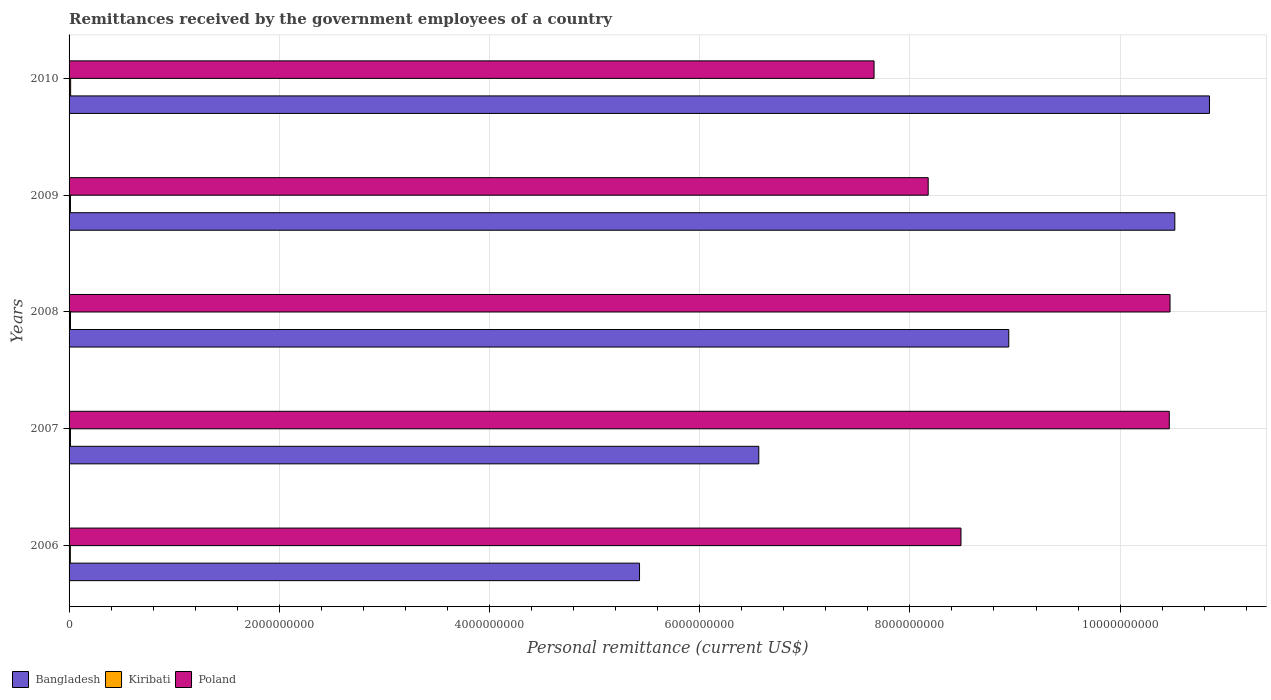Are the number of bars per tick equal to the number of legend labels?
Give a very brief answer. Yes. How many bars are there on the 2nd tick from the top?
Provide a short and direct response. 3. How many bars are there on the 1st tick from the bottom?
Ensure brevity in your answer.  3. What is the label of the 4th group of bars from the top?
Keep it short and to the point. 2007. What is the remittances received by the government employees in Poland in 2007?
Your answer should be very brief. 1.05e+1. Across all years, what is the maximum remittances received by the government employees in Bangladesh?
Your answer should be compact. 1.09e+1. Across all years, what is the minimum remittances received by the government employees in Poland?
Provide a short and direct response. 7.66e+09. What is the total remittances received by the government employees in Kiribati in the graph?
Make the answer very short. 6.64e+07. What is the difference between the remittances received by the government employees in Kiribati in 2006 and that in 2009?
Your answer should be very brief. -1.09e+06. What is the difference between the remittances received by the government employees in Bangladesh in 2010 and the remittances received by the government employees in Kiribati in 2006?
Offer a terse response. 1.08e+1. What is the average remittances received by the government employees in Kiribati per year?
Make the answer very short. 1.33e+07. In the year 2007, what is the difference between the remittances received by the government employees in Kiribati and remittances received by the government employees in Poland?
Your response must be concise. -1.05e+1. What is the ratio of the remittances received by the government employees in Kiribati in 2009 to that in 2010?
Offer a very short reply. 0.88. What is the difference between the highest and the second highest remittances received by the government employees in Kiribati?
Provide a short and direct response. 1.62e+06. What is the difference between the highest and the lowest remittances received by the government employees in Poland?
Keep it short and to the point. 2.82e+09. Is the sum of the remittances received by the government employees in Kiribati in 2006 and 2008 greater than the maximum remittances received by the government employees in Bangladesh across all years?
Ensure brevity in your answer.  No. What does the 2nd bar from the top in 2009 represents?
Offer a very short reply. Kiribati. How many bars are there?
Your answer should be very brief. 15. How many years are there in the graph?
Your answer should be compact. 5. What is the difference between two consecutive major ticks on the X-axis?
Provide a short and direct response. 2.00e+09. Does the graph contain grids?
Offer a very short reply. Yes. Where does the legend appear in the graph?
Make the answer very short. Bottom left. How are the legend labels stacked?
Give a very brief answer. Horizontal. What is the title of the graph?
Your answer should be compact. Remittances received by the government employees of a country. Does "Vietnam" appear as one of the legend labels in the graph?
Offer a very short reply. No. What is the label or title of the X-axis?
Your answer should be compact. Personal remittance (current US$). What is the Personal remittance (current US$) of Bangladesh in 2006?
Your answer should be compact. 5.43e+09. What is the Personal remittance (current US$) of Kiribati in 2006?
Make the answer very short. 1.21e+07. What is the Personal remittance (current US$) of Poland in 2006?
Offer a terse response. 8.49e+09. What is the Personal remittance (current US$) of Bangladesh in 2007?
Provide a succinct answer. 6.56e+09. What is the Personal remittance (current US$) in Kiribati in 2007?
Your response must be concise. 1.29e+07. What is the Personal remittance (current US$) of Poland in 2007?
Keep it short and to the point. 1.05e+1. What is the Personal remittance (current US$) in Bangladesh in 2008?
Make the answer very short. 8.94e+09. What is the Personal remittance (current US$) in Kiribati in 2008?
Provide a short and direct response. 1.33e+07. What is the Personal remittance (current US$) of Poland in 2008?
Provide a short and direct response. 1.05e+1. What is the Personal remittance (current US$) in Bangladesh in 2009?
Offer a very short reply. 1.05e+1. What is the Personal remittance (current US$) in Kiribati in 2009?
Keep it short and to the point. 1.32e+07. What is the Personal remittance (current US$) of Poland in 2009?
Give a very brief answer. 8.17e+09. What is the Personal remittance (current US$) of Bangladesh in 2010?
Offer a terse response. 1.09e+1. What is the Personal remittance (current US$) in Kiribati in 2010?
Provide a succinct answer. 1.49e+07. What is the Personal remittance (current US$) in Poland in 2010?
Give a very brief answer. 7.66e+09. Across all years, what is the maximum Personal remittance (current US$) in Bangladesh?
Provide a succinct answer. 1.09e+1. Across all years, what is the maximum Personal remittance (current US$) in Kiribati?
Make the answer very short. 1.49e+07. Across all years, what is the maximum Personal remittance (current US$) in Poland?
Provide a short and direct response. 1.05e+1. Across all years, what is the minimum Personal remittance (current US$) in Bangladesh?
Give a very brief answer. 5.43e+09. Across all years, what is the minimum Personal remittance (current US$) of Kiribati?
Offer a terse response. 1.21e+07. Across all years, what is the minimum Personal remittance (current US$) of Poland?
Offer a very short reply. 7.66e+09. What is the total Personal remittance (current US$) in Bangladesh in the graph?
Keep it short and to the point. 4.23e+1. What is the total Personal remittance (current US$) in Kiribati in the graph?
Give a very brief answer. 6.64e+07. What is the total Personal remittance (current US$) of Poland in the graph?
Provide a short and direct response. 4.53e+1. What is the difference between the Personal remittance (current US$) in Bangladesh in 2006 and that in 2007?
Ensure brevity in your answer.  -1.13e+09. What is the difference between the Personal remittance (current US$) in Kiribati in 2006 and that in 2007?
Keep it short and to the point. -8.37e+05. What is the difference between the Personal remittance (current US$) in Poland in 2006 and that in 2007?
Ensure brevity in your answer.  -1.98e+09. What is the difference between the Personal remittance (current US$) in Bangladesh in 2006 and that in 2008?
Offer a terse response. -3.51e+09. What is the difference between the Personal remittance (current US$) of Kiribati in 2006 and that in 2008?
Make the answer very short. -1.21e+06. What is the difference between the Personal remittance (current US$) in Poland in 2006 and that in 2008?
Make the answer very short. -1.99e+09. What is the difference between the Personal remittance (current US$) of Bangladesh in 2006 and that in 2009?
Make the answer very short. -5.09e+09. What is the difference between the Personal remittance (current US$) in Kiribati in 2006 and that in 2009?
Give a very brief answer. -1.09e+06. What is the difference between the Personal remittance (current US$) in Poland in 2006 and that in 2009?
Your answer should be compact. 3.12e+08. What is the difference between the Personal remittance (current US$) in Bangladesh in 2006 and that in 2010?
Your answer should be compact. -5.42e+09. What is the difference between the Personal remittance (current US$) in Kiribati in 2006 and that in 2010?
Ensure brevity in your answer.  -2.83e+06. What is the difference between the Personal remittance (current US$) of Poland in 2006 and that in 2010?
Your answer should be very brief. 8.27e+08. What is the difference between the Personal remittance (current US$) of Bangladesh in 2007 and that in 2008?
Ensure brevity in your answer.  -2.38e+09. What is the difference between the Personal remittance (current US$) in Kiribati in 2007 and that in 2008?
Make the answer very short. -3.76e+05. What is the difference between the Personal remittance (current US$) in Poland in 2007 and that in 2008?
Your answer should be compact. -7.00e+06. What is the difference between the Personal remittance (current US$) of Bangladesh in 2007 and that in 2009?
Provide a short and direct response. -3.96e+09. What is the difference between the Personal remittance (current US$) in Kiribati in 2007 and that in 2009?
Provide a succinct answer. -2.53e+05. What is the difference between the Personal remittance (current US$) in Poland in 2007 and that in 2009?
Your answer should be compact. 2.29e+09. What is the difference between the Personal remittance (current US$) of Bangladesh in 2007 and that in 2010?
Make the answer very short. -4.29e+09. What is the difference between the Personal remittance (current US$) of Kiribati in 2007 and that in 2010?
Ensure brevity in your answer.  -1.99e+06. What is the difference between the Personal remittance (current US$) of Poland in 2007 and that in 2010?
Offer a terse response. 2.81e+09. What is the difference between the Personal remittance (current US$) of Bangladesh in 2008 and that in 2009?
Give a very brief answer. -1.58e+09. What is the difference between the Personal remittance (current US$) in Kiribati in 2008 and that in 2009?
Offer a very short reply. 1.23e+05. What is the difference between the Personal remittance (current US$) of Poland in 2008 and that in 2009?
Your response must be concise. 2.30e+09. What is the difference between the Personal remittance (current US$) in Bangladesh in 2008 and that in 2010?
Provide a short and direct response. -1.91e+09. What is the difference between the Personal remittance (current US$) in Kiribati in 2008 and that in 2010?
Your answer should be compact. -1.62e+06. What is the difference between the Personal remittance (current US$) of Poland in 2008 and that in 2010?
Keep it short and to the point. 2.82e+09. What is the difference between the Personal remittance (current US$) of Bangladesh in 2009 and that in 2010?
Give a very brief answer. -3.30e+08. What is the difference between the Personal remittance (current US$) in Kiribati in 2009 and that in 2010?
Ensure brevity in your answer.  -1.74e+06. What is the difference between the Personal remittance (current US$) of Poland in 2009 and that in 2010?
Offer a very short reply. 5.15e+08. What is the difference between the Personal remittance (current US$) in Bangladesh in 2006 and the Personal remittance (current US$) in Kiribati in 2007?
Ensure brevity in your answer.  5.41e+09. What is the difference between the Personal remittance (current US$) of Bangladesh in 2006 and the Personal remittance (current US$) of Poland in 2007?
Provide a succinct answer. -5.04e+09. What is the difference between the Personal remittance (current US$) in Kiribati in 2006 and the Personal remittance (current US$) in Poland in 2007?
Your response must be concise. -1.05e+1. What is the difference between the Personal remittance (current US$) in Bangladesh in 2006 and the Personal remittance (current US$) in Kiribati in 2008?
Your answer should be compact. 5.41e+09. What is the difference between the Personal remittance (current US$) in Bangladesh in 2006 and the Personal remittance (current US$) in Poland in 2008?
Keep it short and to the point. -5.05e+09. What is the difference between the Personal remittance (current US$) of Kiribati in 2006 and the Personal remittance (current US$) of Poland in 2008?
Your answer should be very brief. -1.05e+1. What is the difference between the Personal remittance (current US$) in Bangladesh in 2006 and the Personal remittance (current US$) in Kiribati in 2009?
Give a very brief answer. 5.41e+09. What is the difference between the Personal remittance (current US$) in Bangladesh in 2006 and the Personal remittance (current US$) in Poland in 2009?
Give a very brief answer. -2.75e+09. What is the difference between the Personal remittance (current US$) in Kiribati in 2006 and the Personal remittance (current US$) in Poland in 2009?
Give a very brief answer. -8.16e+09. What is the difference between the Personal remittance (current US$) in Bangladesh in 2006 and the Personal remittance (current US$) in Kiribati in 2010?
Make the answer very short. 5.41e+09. What is the difference between the Personal remittance (current US$) in Bangladesh in 2006 and the Personal remittance (current US$) in Poland in 2010?
Keep it short and to the point. -2.23e+09. What is the difference between the Personal remittance (current US$) in Kiribati in 2006 and the Personal remittance (current US$) in Poland in 2010?
Provide a short and direct response. -7.65e+09. What is the difference between the Personal remittance (current US$) in Bangladesh in 2007 and the Personal remittance (current US$) in Kiribati in 2008?
Your response must be concise. 6.55e+09. What is the difference between the Personal remittance (current US$) in Bangladesh in 2007 and the Personal remittance (current US$) in Poland in 2008?
Your response must be concise. -3.91e+09. What is the difference between the Personal remittance (current US$) of Kiribati in 2007 and the Personal remittance (current US$) of Poland in 2008?
Provide a short and direct response. -1.05e+1. What is the difference between the Personal remittance (current US$) in Bangladesh in 2007 and the Personal remittance (current US$) in Kiribati in 2009?
Your answer should be compact. 6.55e+09. What is the difference between the Personal remittance (current US$) in Bangladesh in 2007 and the Personal remittance (current US$) in Poland in 2009?
Make the answer very short. -1.61e+09. What is the difference between the Personal remittance (current US$) in Kiribati in 2007 and the Personal remittance (current US$) in Poland in 2009?
Make the answer very short. -8.16e+09. What is the difference between the Personal remittance (current US$) of Bangladesh in 2007 and the Personal remittance (current US$) of Kiribati in 2010?
Provide a succinct answer. 6.55e+09. What is the difference between the Personal remittance (current US$) of Bangladesh in 2007 and the Personal remittance (current US$) of Poland in 2010?
Your answer should be compact. -1.10e+09. What is the difference between the Personal remittance (current US$) in Kiribati in 2007 and the Personal remittance (current US$) in Poland in 2010?
Keep it short and to the point. -7.65e+09. What is the difference between the Personal remittance (current US$) of Bangladesh in 2008 and the Personal remittance (current US$) of Kiribati in 2009?
Offer a terse response. 8.93e+09. What is the difference between the Personal remittance (current US$) in Bangladesh in 2008 and the Personal remittance (current US$) in Poland in 2009?
Make the answer very short. 7.67e+08. What is the difference between the Personal remittance (current US$) of Kiribati in 2008 and the Personal remittance (current US$) of Poland in 2009?
Your response must be concise. -8.16e+09. What is the difference between the Personal remittance (current US$) of Bangladesh in 2008 and the Personal remittance (current US$) of Kiribati in 2010?
Offer a very short reply. 8.93e+09. What is the difference between the Personal remittance (current US$) of Bangladesh in 2008 and the Personal remittance (current US$) of Poland in 2010?
Your answer should be compact. 1.28e+09. What is the difference between the Personal remittance (current US$) in Kiribati in 2008 and the Personal remittance (current US$) in Poland in 2010?
Your response must be concise. -7.65e+09. What is the difference between the Personal remittance (current US$) of Bangladesh in 2009 and the Personal remittance (current US$) of Kiribati in 2010?
Your response must be concise. 1.05e+1. What is the difference between the Personal remittance (current US$) of Bangladesh in 2009 and the Personal remittance (current US$) of Poland in 2010?
Your response must be concise. 2.86e+09. What is the difference between the Personal remittance (current US$) in Kiribati in 2009 and the Personal remittance (current US$) in Poland in 2010?
Provide a succinct answer. -7.65e+09. What is the average Personal remittance (current US$) of Bangladesh per year?
Your answer should be compact. 8.46e+09. What is the average Personal remittance (current US$) of Kiribati per year?
Your answer should be very brief. 1.33e+07. What is the average Personal remittance (current US$) of Poland per year?
Provide a short and direct response. 9.05e+09. In the year 2006, what is the difference between the Personal remittance (current US$) in Bangladesh and Personal remittance (current US$) in Kiribati?
Offer a terse response. 5.42e+09. In the year 2006, what is the difference between the Personal remittance (current US$) of Bangladesh and Personal remittance (current US$) of Poland?
Provide a succinct answer. -3.06e+09. In the year 2006, what is the difference between the Personal remittance (current US$) in Kiribati and Personal remittance (current US$) in Poland?
Your response must be concise. -8.47e+09. In the year 2007, what is the difference between the Personal remittance (current US$) in Bangladesh and Personal remittance (current US$) in Kiribati?
Your answer should be very brief. 6.55e+09. In the year 2007, what is the difference between the Personal remittance (current US$) of Bangladesh and Personal remittance (current US$) of Poland?
Keep it short and to the point. -3.91e+09. In the year 2007, what is the difference between the Personal remittance (current US$) in Kiribati and Personal remittance (current US$) in Poland?
Make the answer very short. -1.05e+1. In the year 2008, what is the difference between the Personal remittance (current US$) in Bangladesh and Personal remittance (current US$) in Kiribati?
Offer a very short reply. 8.93e+09. In the year 2008, what is the difference between the Personal remittance (current US$) in Bangladesh and Personal remittance (current US$) in Poland?
Your response must be concise. -1.53e+09. In the year 2008, what is the difference between the Personal remittance (current US$) of Kiribati and Personal remittance (current US$) of Poland?
Your answer should be very brief. -1.05e+1. In the year 2009, what is the difference between the Personal remittance (current US$) of Bangladesh and Personal remittance (current US$) of Kiribati?
Provide a succinct answer. 1.05e+1. In the year 2009, what is the difference between the Personal remittance (current US$) in Bangladesh and Personal remittance (current US$) in Poland?
Ensure brevity in your answer.  2.35e+09. In the year 2009, what is the difference between the Personal remittance (current US$) of Kiribati and Personal remittance (current US$) of Poland?
Make the answer very short. -8.16e+09. In the year 2010, what is the difference between the Personal remittance (current US$) in Bangladesh and Personal remittance (current US$) in Kiribati?
Provide a short and direct response. 1.08e+1. In the year 2010, what is the difference between the Personal remittance (current US$) of Bangladesh and Personal remittance (current US$) of Poland?
Offer a very short reply. 3.19e+09. In the year 2010, what is the difference between the Personal remittance (current US$) in Kiribati and Personal remittance (current US$) in Poland?
Keep it short and to the point. -7.64e+09. What is the ratio of the Personal remittance (current US$) of Bangladesh in 2006 to that in 2007?
Offer a terse response. 0.83. What is the ratio of the Personal remittance (current US$) of Kiribati in 2006 to that in 2007?
Ensure brevity in your answer.  0.94. What is the ratio of the Personal remittance (current US$) in Poland in 2006 to that in 2007?
Your response must be concise. 0.81. What is the ratio of the Personal remittance (current US$) in Bangladesh in 2006 to that in 2008?
Your answer should be very brief. 0.61. What is the ratio of the Personal remittance (current US$) of Kiribati in 2006 to that in 2008?
Ensure brevity in your answer.  0.91. What is the ratio of the Personal remittance (current US$) of Poland in 2006 to that in 2008?
Make the answer very short. 0.81. What is the ratio of the Personal remittance (current US$) in Bangladesh in 2006 to that in 2009?
Give a very brief answer. 0.52. What is the ratio of the Personal remittance (current US$) of Kiribati in 2006 to that in 2009?
Provide a succinct answer. 0.92. What is the ratio of the Personal remittance (current US$) of Poland in 2006 to that in 2009?
Make the answer very short. 1.04. What is the ratio of the Personal remittance (current US$) of Bangladesh in 2006 to that in 2010?
Your answer should be very brief. 0.5. What is the ratio of the Personal remittance (current US$) in Kiribati in 2006 to that in 2010?
Offer a very short reply. 0.81. What is the ratio of the Personal remittance (current US$) of Poland in 2006 to that in 2010?
Keep it short and to the point. 1.11. What is the ratio of the Personal remittance (current US$) of Bangladesh in 2007 to that in 2008?
Make the answer very short. 0.73. What is the ratio of the Personal remittance (current US$) of Kiribati in 2007 to that in 2008?
Provide a succinct answer. 0.97. What is the ratio of the Personal remittance (current US$) in Poland in 2007 to that in 2008?
Offer a terse response. 1. What is the ratio of the Personal remittance (current US$) of Bangladesh in 2007 to that in 2009?
Offer a terse response. 0.62. What is the ratio of the Personal remittance (current US$) in Kiribati in 2007 to that in 2009?
Keep it short and to the point. 0.98. What is the ratio of the Personal remittance (current US$) of Poland in 2007 to that in 2009?
Make the answer very short. 1.28. What is the ratio of the Personal remittance (current US$) in Bangladesh in 2007 to that in 2010?
Ensure brevity in your answer.  0.6. What is the ratio of the Personal remittance (current US$) in Kiribati in 2007 to that in 2010?
Your answer should be very brief. 0.87. What is the ratio of the Personal remittance (current US$) of Poland in 2007 to that in 2010?
Provide a short and direct response. 1.37. What is the ratio of the Personal remittance (current US$) of Bangladesh in 2008 to that in 2009?
Provide a short and direct response. 0.85. What is the ratio of the Personal remittance (current US$) in Kiribati in 2008 to that in 2009?
Provide a short and direct response. 1.01. What is the ratio of the Personal remittance (current US$) in Poland in 2008 to that in 2009?
Give a very brief answer. 1.28. What is the ratio of the Personal remittance (current US$) of Bangladesh in 2008 to that in 2010?
Your answer should be very brief. 0.82. What is the ratio of the Personal remittance (current US$) of Kiribati in 2008 to that in 2010?
Offer a very short reply. 0.89. What is the ratio of the Personal remittance (current US$) of Poland in 2008 to that in 2010?
Make the answer very short. 1.37. What is the ratio of the Personal remittance (current US$) in Bangladesh in 2009 to that in 2010?
Give a very brief answer. 0.97. What is the ratio of the Personal remittance (current US$) of Kiribati in 2009 to that in 2010?
Provide a short and direct response. 0.88. What is the ratio of the Personal remittance (current US$) in Poland in 2009 to that in 2010?
Offer a terse response. 1.07. What is the difference between the highest and the second highest Personal remittance (current US$) of Bangladesh?
Your response must be concise. 3.30e+08. What is the difference between the highest and the second highest Personal remittance (current US$) of Kiribati?
Keep it short and to the point. 1.62e+06. What is the difference between the highest and the lowest Personal remittance (current US$) of Bangladesh?
Provide a succinct answer. 5.42e+09. What is the difference between the highest and the lowest Personal remittance (current US$) of Kiribati?
Make the answer very short. 2.83e+06. What is the difference between the highest and the lowest Personal remittance (current US$) in Poland?
Offer a very short reply. 2.82e+09. 